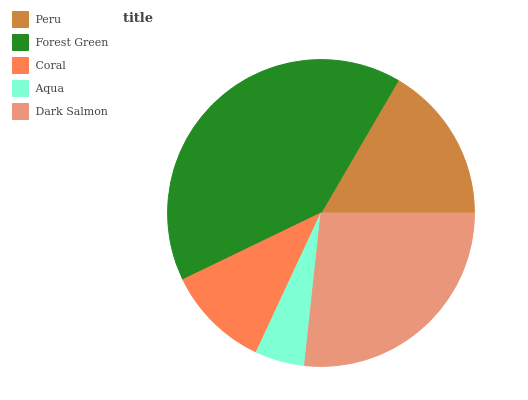Is Aqua the minimum?
Answer yes or no. Yes. Is Forest Green the maximum?
Answer yes or no. Yes. Is Coral the minimum?
Answer yes or no. No. Is Coral the maximum?
Answer yes or no. No. Is Forest Green greater than Coral?
Answer yes or no. Yes. Is Coral less than Forest Green?
Answer yes or no. Yes. Is Coral greater than Forest Green?
Answer yes or no. No. Is Forest Green less than Coral?
Answer yes or no. No. Is Peru the high median?
Answer yes or no. Yes. Is Peru the low median?
Answer yes or no. Yes. Is Dark Salmon the high median?
Answer yes or no. No. Is Aqua the low median?
Answer yes or no. No. 